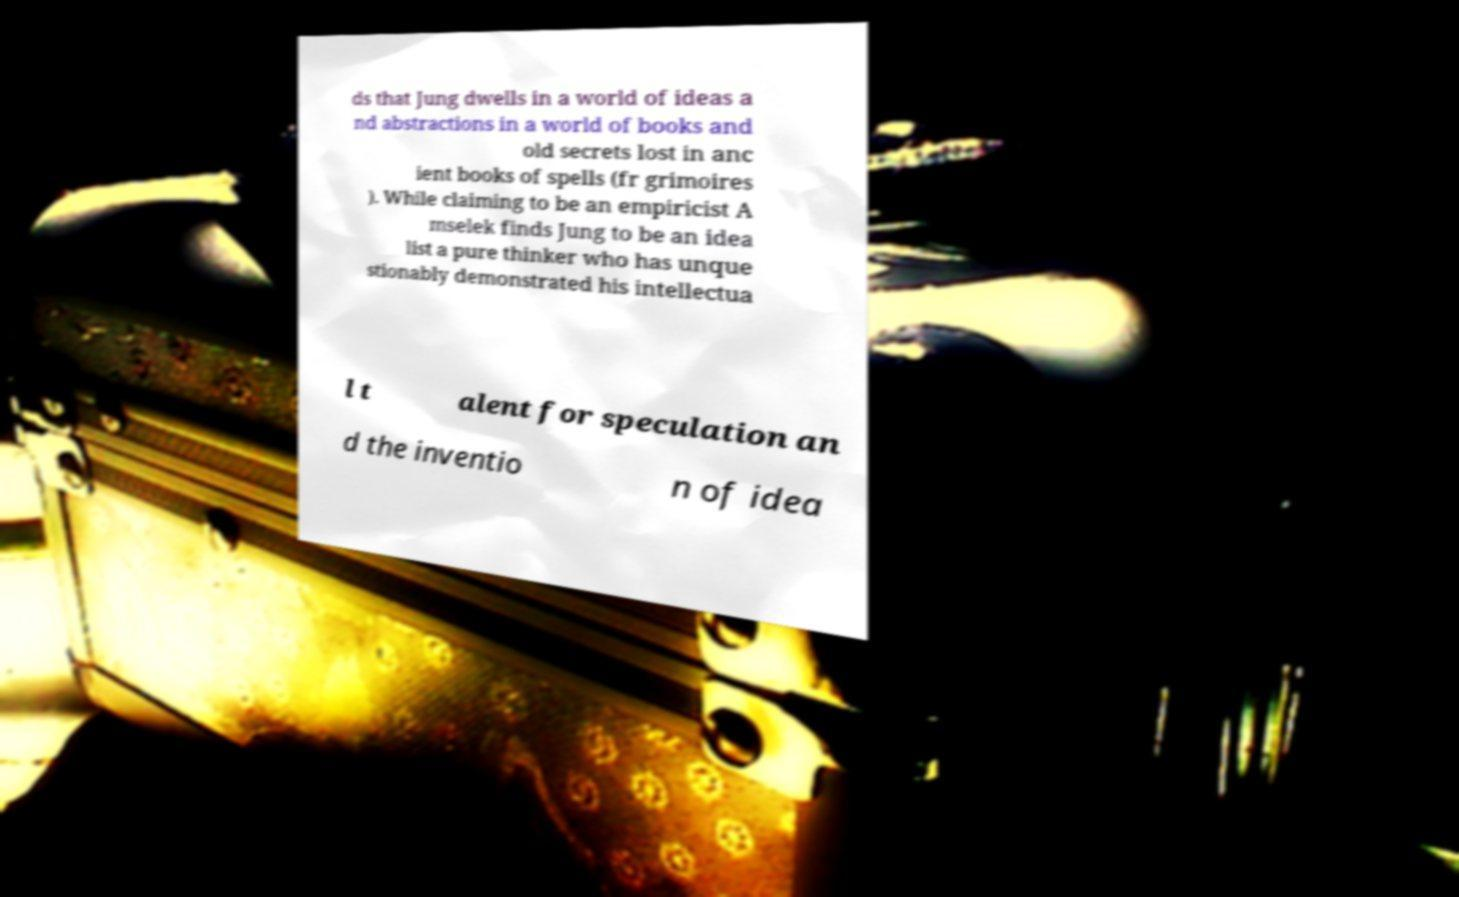What messages or text are displayed in this image? I need them in a readable, typed format. ds that Jung dwells in a world of ideas a nd abstractions in a world of books and old secrets lost in anc ient books of spells (fr grimoires ). While claiming to be an empiricist A mselek finds Jung to be an idea list a pure thinker who has unque stionably demonstrated his intellectua l t alent for speculation an d the inventio n of idea 